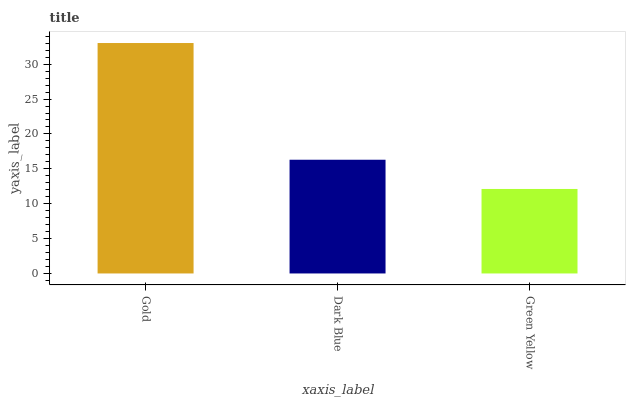Is Dark Blue the minimum?
Answer yes or no. No. Is Dark Blue the maximum?
Answer yes or no. No. Is Gold greater than Dark Blue?
Answer yes or no. Yes. Is Dark Blue less than Gold?
Answer yes or no. Yes. Is Dark Blue greater than Gold?
Answer yes or no. No. Is Gold less than Dark Blue?
Answer yes or no. No. Is Dark Blue the high median?
Answer yes or no. Yes. Is Dark Blue the low median?
Answer yes or no. Yes. Is Gold the high median?
Answer yes or no. No. Is Green Yellow the low median?
Answer yes or no. No. 